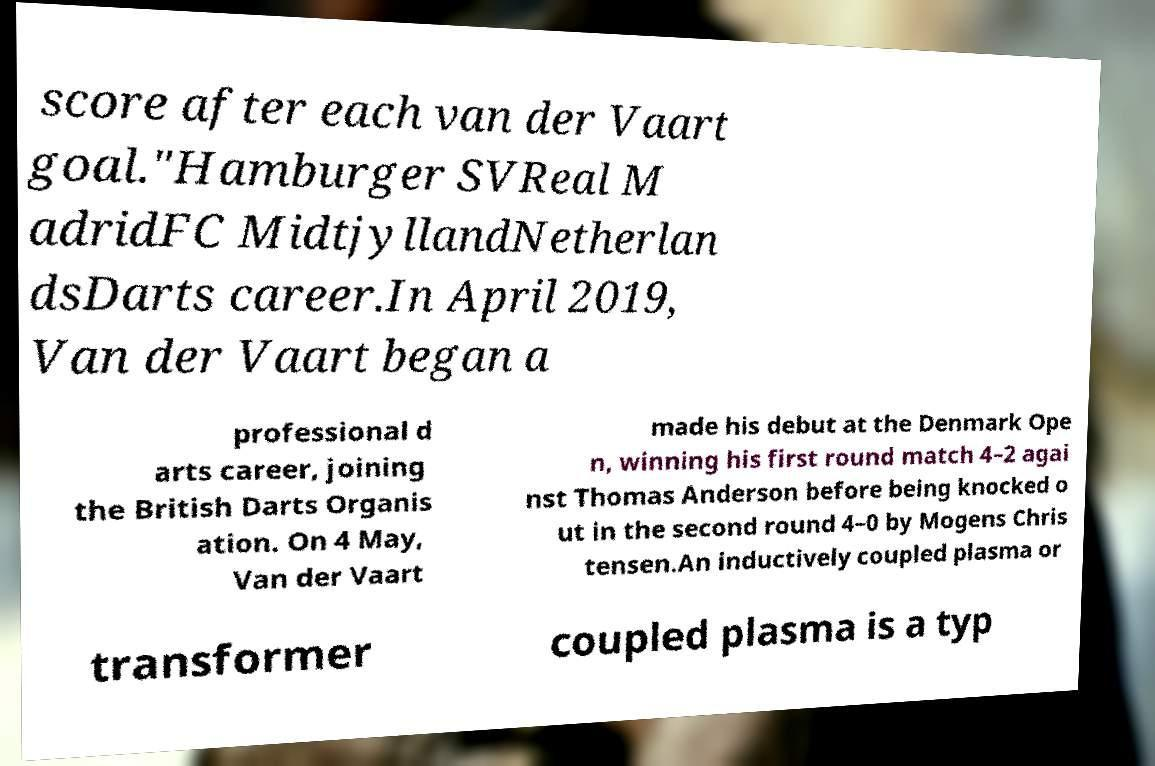Could you extract and type out the text from this image? score after each van der Vaart goal."Hamburger SVReal M adridFC MidtjyllandNetherlan dsDarts career.In April 2019, Van der Vaart began a professional d arts career, joining the British Darts Organis ation. On 4 May, Van der Vaart made his debut at the Denmark Ope n, winning his first round match 4–2 agai nst Thomas Anderson before being knocked o ut in the second round 4–0 by Mogens Chris tensen.An inductively coupled plasma or transformer coupled plasma is a typ 